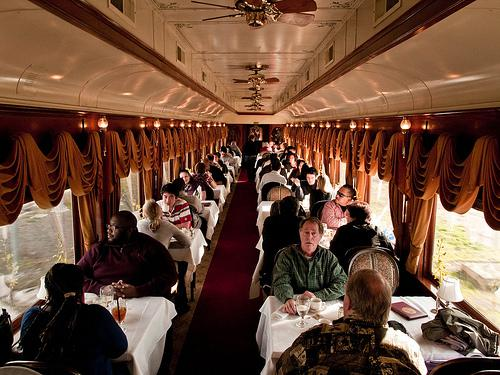Question: what are the people doing?
Choices:
A. Dining.
B. Swimming.
C. Running.
D. Looking.
Answer with the letter. Answer: A Question: what are the people in?
Choices:
A. A car.
B. A train.
C. A house.
D. A mall.
Answer with the letter. Answer: B Question: what color are the curtains?
Choices:
A. Gold.
B. Green.
C. White.
D. Grey.
Answer with the letter. Answer: A Question: how many rows of tables are on the train?
Choices:
A. 3.
B. 4.
C. 5.
D. 2.
Answer with the letter. Answer: D 